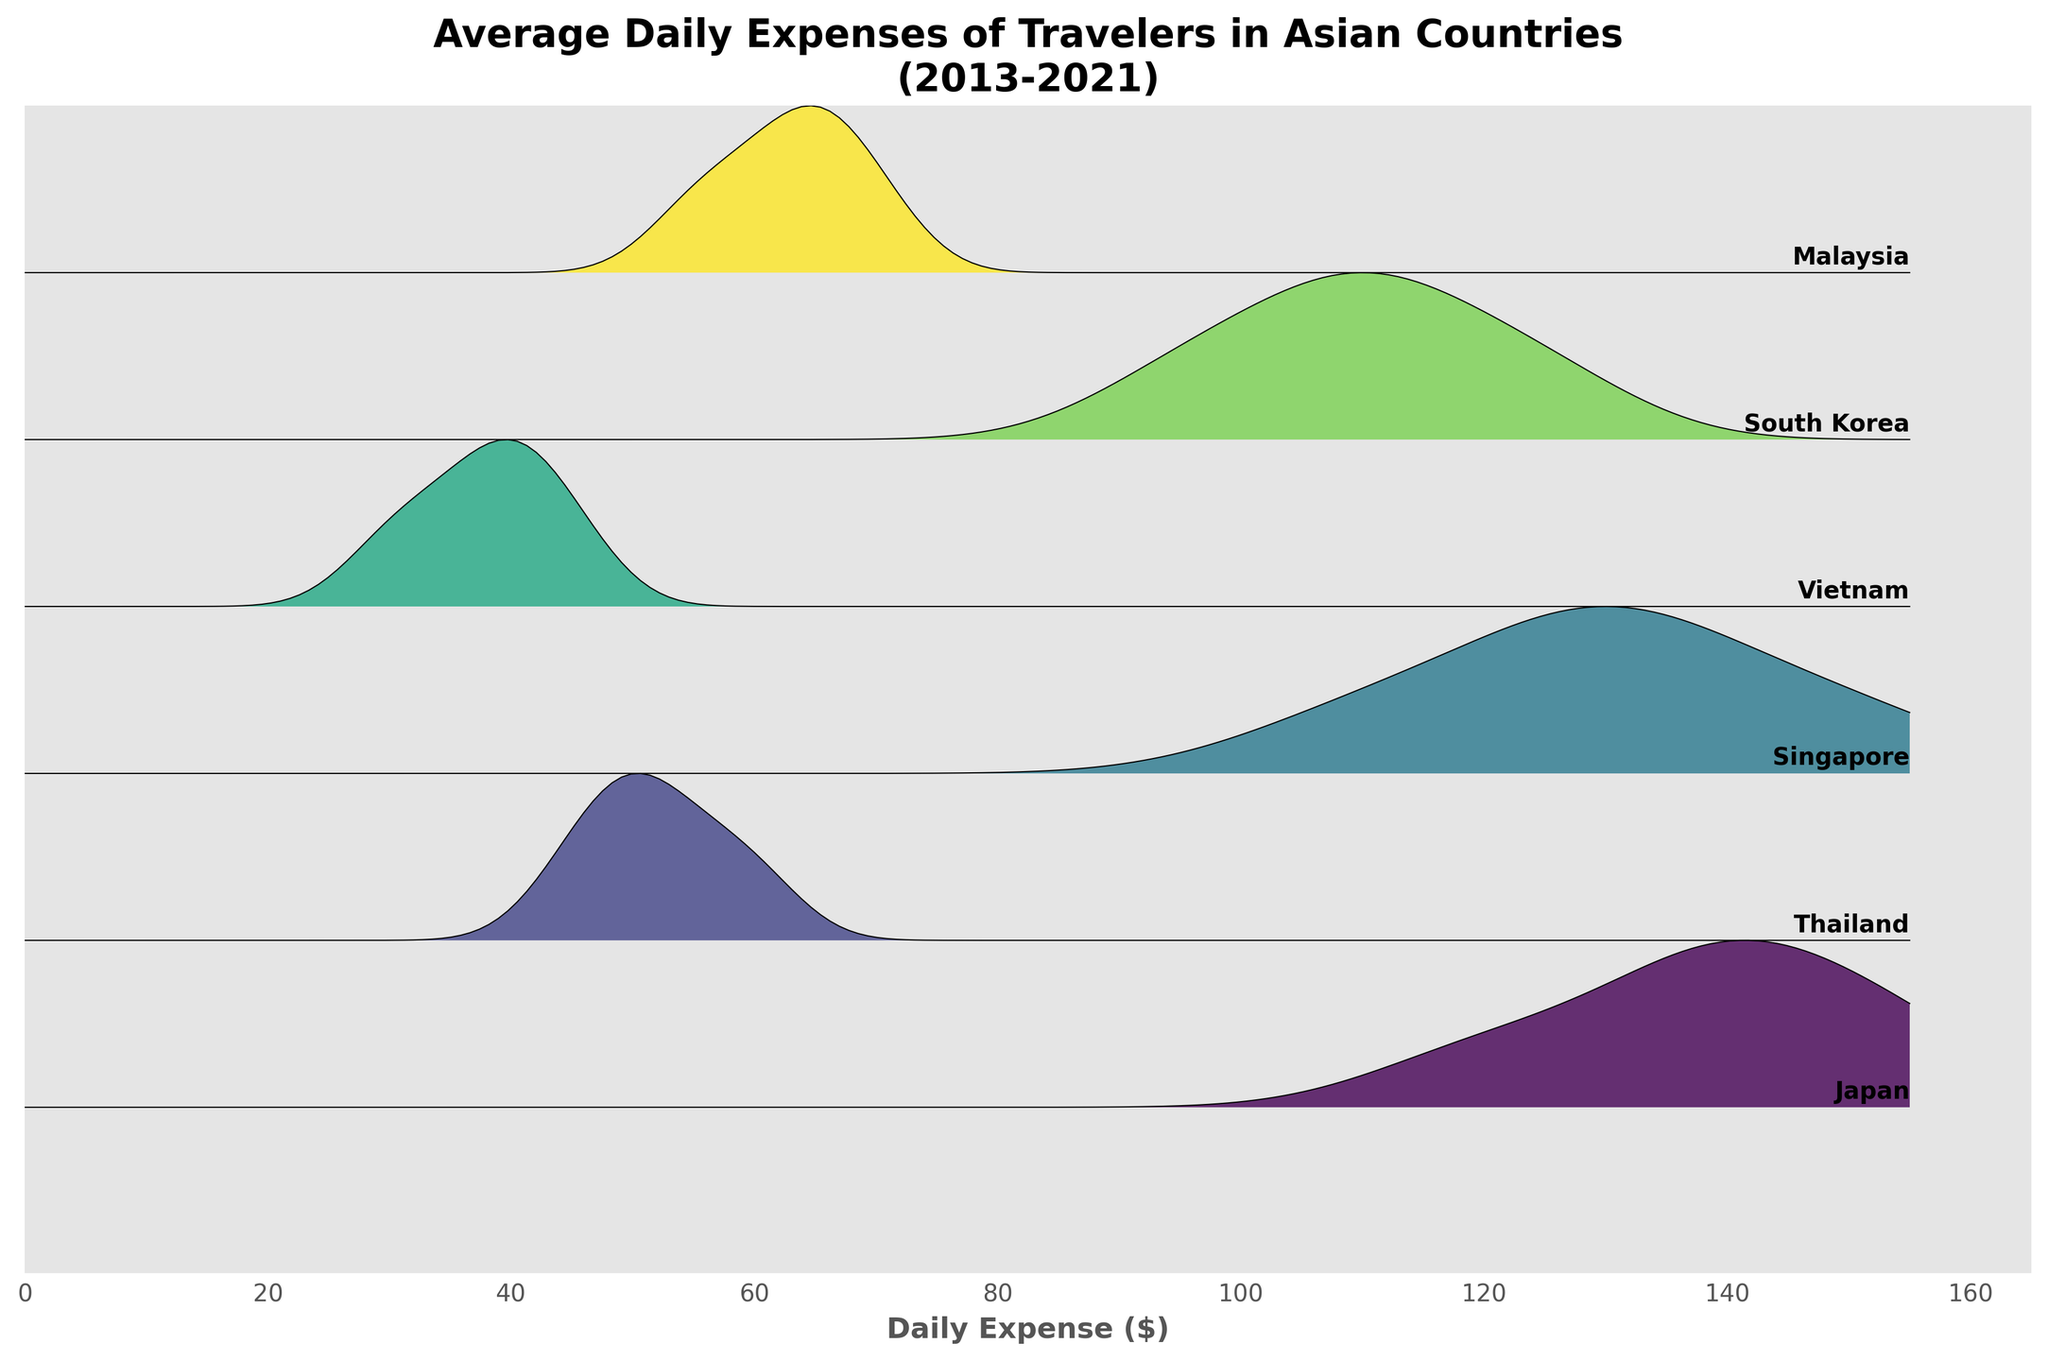What's the title of the figure? The title of a figure is usually displayed at the top of the plot. Here, we see "Average Daily Expenses of Travelers in Asian Countries\n(2013-2021)" as the title at the top of the plot.
Answer: Average Daily Expenses of Travelers in Asian Countries (2013-2021) Which country has the highest daily expenses in 2021? In the ridgeline plot, each country is represented by a "ridge". By examining the height of the highest ridge in 2021, we see Japan reaches the highest expense around $140.
Answer: Japan How did the daily expenses in Singapore change from 2013 to 2019? We need to compare the heights and positions of the ridges for Singapore in 2013 and 2019. From 2013 ($110) to 2019 ($150), Singapore's daily expenses show an increasing trend.
Answer: Increased by $40 Which country had the lowest daily expenses in 2013? We look for the lowest ridge in 2013. The height of Vietnam's ridge indicates it has the lowest daily expense around $30.
Answer: Vietnam Compare the daily expenses of Japan and Malaysia in 2019. Which country had higher expenses and by how much? By comparing the heights of the ridges for Japan and Malaysia in 2019, we see Japan has a higher expense ($155) compared to Malaysia ($70). The difference is $155 - $70 = $85.
Answer: Japan, by $85 Are there any countries where daily expenses increased from 2013 to 2019 and then decreased in 2021? We need to check each country's ridges from 2013 to 2019 to 2021. Japan and Singapore both show this pattern: Increase from 2013 to 2019, then a decrease in 2021.
Answer: Japan and Singapore What is the approximate range of daily expenses for travelers across all countries in 2013? By observing the range of all ridges in 2013, we see the minimum value for Vietnam ($30) and the maximum value for Japan and Singapore (both $110). The range is $30 - $110.
Answer: $30 to $110 Which country shows the smallest variation in daily expenses across all recorded years? Check the width and height of the ridges for each country across all years. Vietnam’s ridge appears to show the least change from 2013 to 2021, indicating small variation in expenses.
Answer: Vietnam How do the average daily expenses in South Korea in 2021 compare to those in 2017? Compare the ridges for South Korea in 2017 ($115) and 2021 ($110). The expenses decreased from 2017 to 2021 by $5.
Answer: Decreased by $5 